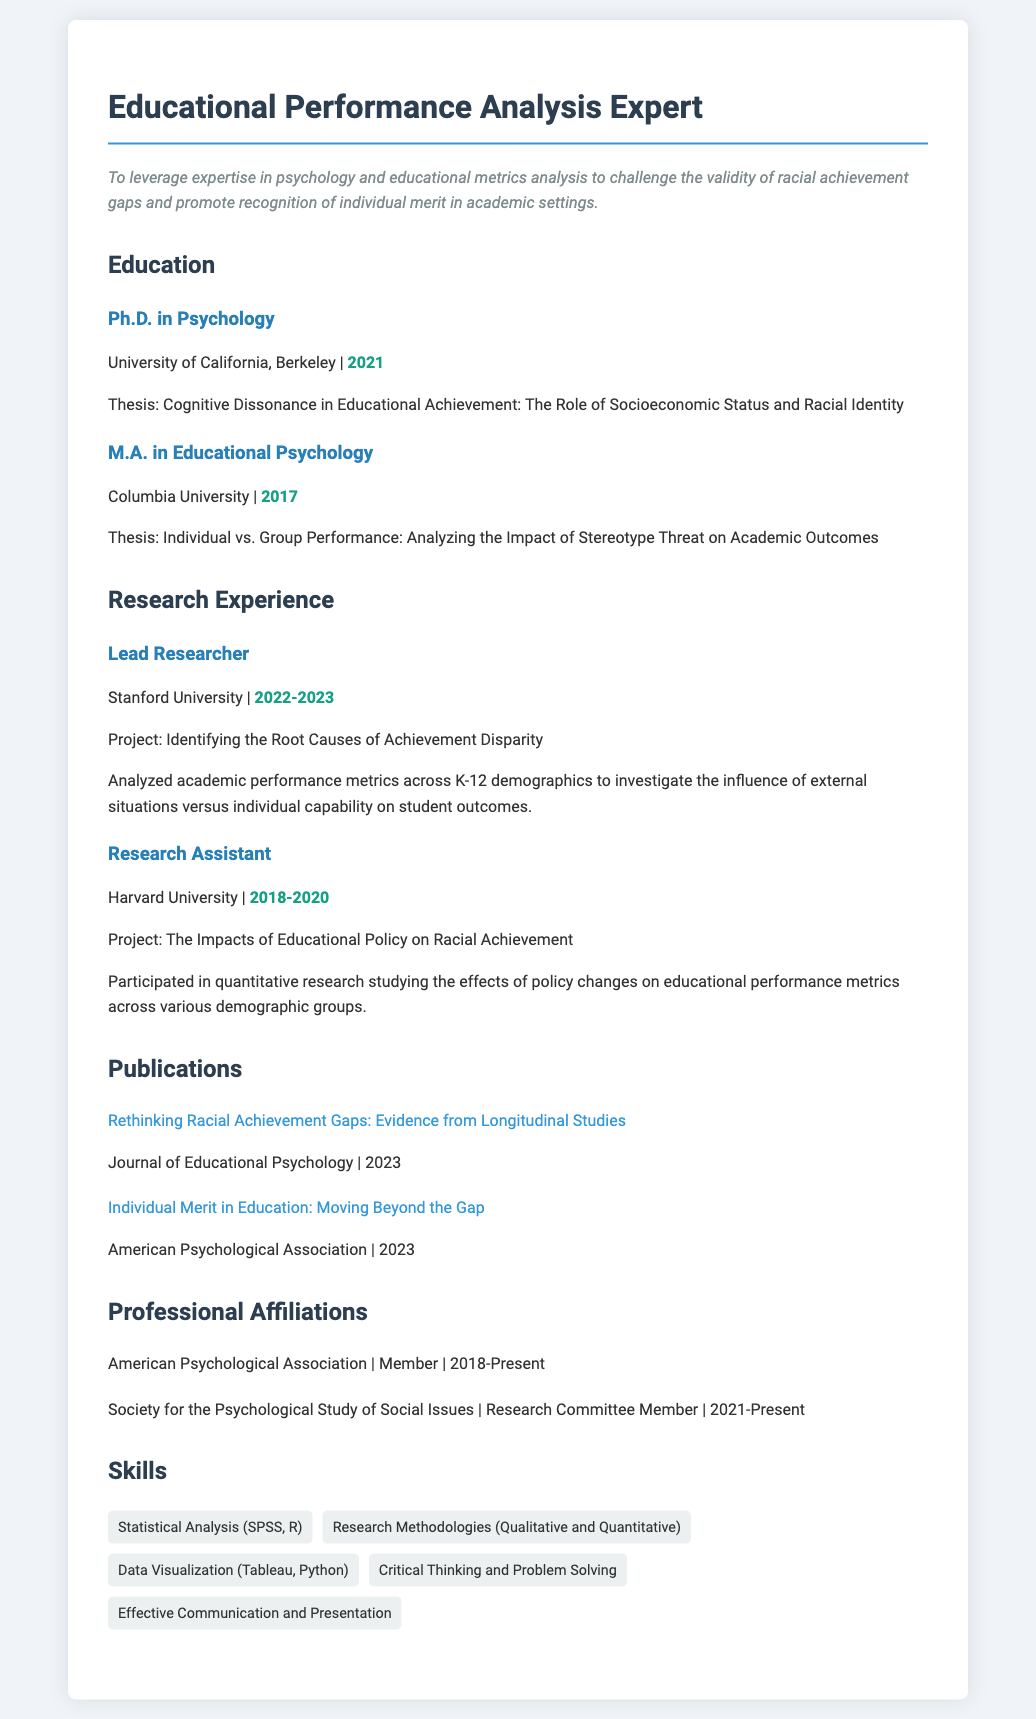What degree does the individual hold? The individual holds a Ph.D. in Psychology as stated in the education section of the document.
Answer: Ph.D. in Psychology What is the focus of the individual's thesis for their Ph.D.? The thesis focuses on cognitive dissonance in educational achievement, examining socioeconomic status and racial identity.
Answer: Cognitive Dissonance in Educational Achievement: The Role of Socioeconomic Status and Racial Identity Which university did the individual obtain their M.A. from? The M.A. was obtained from Columbia University, as listed in the education section.
Answer: Columbia University What year did the individual complete their Ph.D.? The document clearly states that the individual completed their Ph.D. in 2021.
Answer: 2021 What was the project title the individual worked on as a Lead Researcher? The project title is "Identifying the Root Causes of Achievement Disparity," mentioned in the research experience section.
Answer: Identifying the Root Causes of Achievement Disparity Which publication is about individual merit in education? The document indicates that the publication titled "Individual Merit in Education: Moving Beyond the Gap" is relevant to this topic.
Answer: Individual Merit in Education: Moving Beyond the Gap How many years has the individual been a member of the American Psychological Association? The document states the individual has been a member since 2018 and the current year is 2023, making it 5 years.
Answer: 5 years What type of analysis skills does the individual possess according to the skills section? The individual possesses skills in statistical analysis, specifically SPSS and R, highlighted in the skills section.
Answer: Statistical Analysis (SPSS, R) What role did the individual hold at Harvard University? The individual worked as a Research Assistant, as specified in the research experience section.
Answer: Research Assistant 